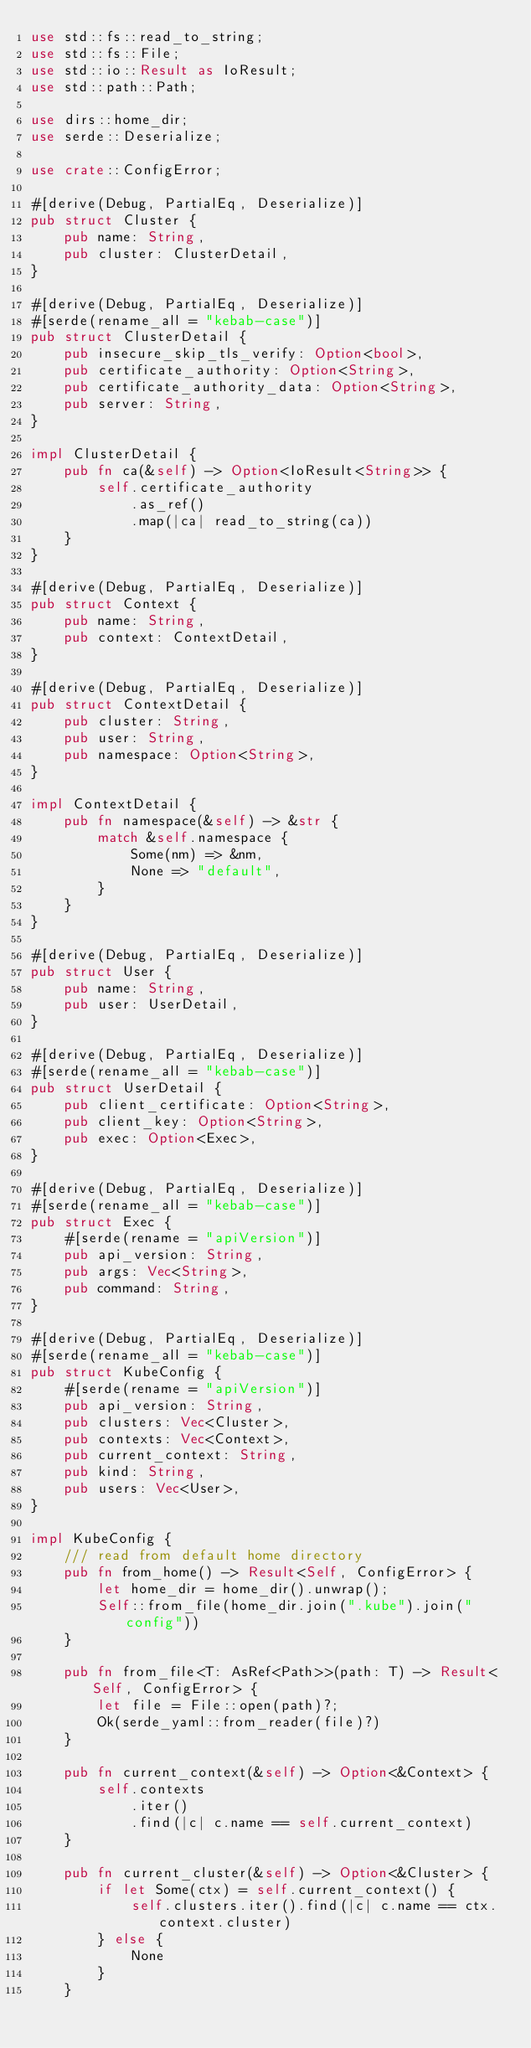Convert code to text. <code><loc_0><loc_0><loc_500><loc_500><_Rust_>use std::fs::read_to_string;
use std::fs::File;
use std::io::Result as IoResult;
use std::path::Path;

use dirs::home_dir;
use serde::Deserialize;

use crate::ConfigError;

#[derive(Debug, PartialEq, Deserialize)]
pub struct Cluster {
    pub name: String,
    pub cluster: ClusterDetail,
}

#[derive(Debug, PartialEq, Deserialize)]
#[serde(rename_all = "kebab-case")]
pub struct ClusterDetail {
    pub insecure_skip_tls_verify: Option<bool>,
    pub certificate_authority: Option<String>,
    pub certificate_authority_data: Option<String>,
    pub server: String,
}

impl ClusterDetail {
    pub fn ca(&self) -> Option<IoResult<String>> {
        self.certificate_authority
            .as_ref()
            .map(|ca| read_to_string(ca))
    }
}

#[derive(Debug, PartialEq, Deserialize)]
pub struct Context {
    pub name: String,
    pub context: ContextDetail,
}

#[derive(Debug, PartialEq, Deserialize)]
pub struct ContextDetail {
    pub cluster: String,
    pub user: String,
    pub namespace: Option<String>,
}

impl ContextDetail {
    pub fn namespace(&self) -> &str {
        match &self.namespace {
            Some(nm) => &nm,
            None => "default",
        }
    }
}

#[derive(Debug, PartialEq, Deserialize)]
pub struct User {
    pub name: String,
    pub user: UserDetail,
}

#[derive(Debug, PartialEq, Deserialize)]
#[serde(rename_all = "kebab-case")]
pub struct UserDetail {
    pub client_certificate: Option<String>,
    pub client_key: Option<String>,
    pub exec: Option<Exec>,
}

#[derive(Debug, PartialEq, Deserialize)]
#[serde(rename_all = "kebab-case")]
pub struct Exec {
    #[serde(rename = "apiVersion")]
    pub api_version: String,
    pub args: Vec<String>,
    pub command: String,
}

#[derive(Debug, PartialEq, Deserialize)]
#[serde(rename_all = "kebab-case")]
pub struct KubeConfig {
    #[serde(rename = "apiVersion")]
    pub api_version: String,
    pub clusters: Vec<Cluster>,
    pub contexts: Vec<Context>,
    pub current_context: String,
    pub kind: String,
    pub users: Vec<User>,
}

impl KubeConfig {
    /// read from default home directory
    pub fn from_home() -> Result<Self, ConfigError> {
        let home_dir = home_dir().unwrap();
        Self::from_file(home_dir.join(".kube").join("config"))
    }

    pub fn from_file<T: AsRef<Path>>(path: T) -> Result<Self, ConfigError> {
        let file = File::open(path)?;
        Ok(serde_yaml::from_reader(file)?)
    }

    pub fn current_context(&self) -> Option<&Context> {
        self.contexts
            .iter()
            .find(|c| c.name == self.current_context)
    }

    pub fn current_cluster(&self) -> Option<&Cluster> {
        if let Some(ctx) = self.current_context() {
            self.clusters.iter().find(|c| c.name == ctx.context.cluster)
        } else {
            None
        }
    }
</code> 